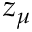Convert formula to latex. <formula><loc_0><loc_0><loc_500><loc_500>z _ { \mu }</formula> 